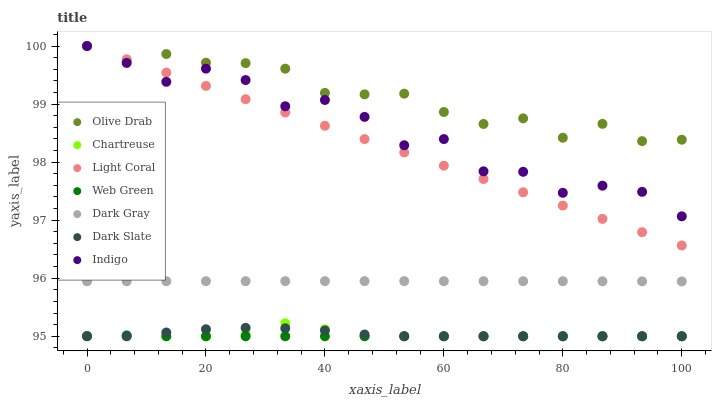Does Web Green have the minimum area under the curve?
Answer yes or no. Yes. Does Olive Drab have the maximum area under the curve?
Answer yes or no. Yes. Does Indigo have the minimum area under the curve?
Answer yes or no. No. Does Indigo have the maximum area under the curve?
Answer yes or no. No. Is Light Coral the smoothest?
Answer yes or no. Yes. Is Indigo the roughest?
Answer yes or no. Yes. Is Web Green the smoothest?
Answer yes or no. No. Is Web Green the roughest?
Answer yes or no. No. Does Web Green have the lowest value?
Answer yes or no. Yes. Does Indigo have the lowest value?
Answer yes or no. No. Does Olive Drab have the highest value?
Answer yes or no. Yes. Does Web Green have the highest value?
Answer yes or no. No. Is Dark Slate less than Dark Gray?
Answer yes or no. Yes. Is Indigo greater than Chartreuse?
Answer yes or no. Yes. Does Indigo intersect Olive Drab?
Answer yes or no. Yes. Is Indigo less than Olive Drab?
Answer yes or no. No. Is Indigo greater than Olive Drab?
Answer yes or no. No. Does Dark Slate intersect Dark Gray?
Answer yes or no. No. 